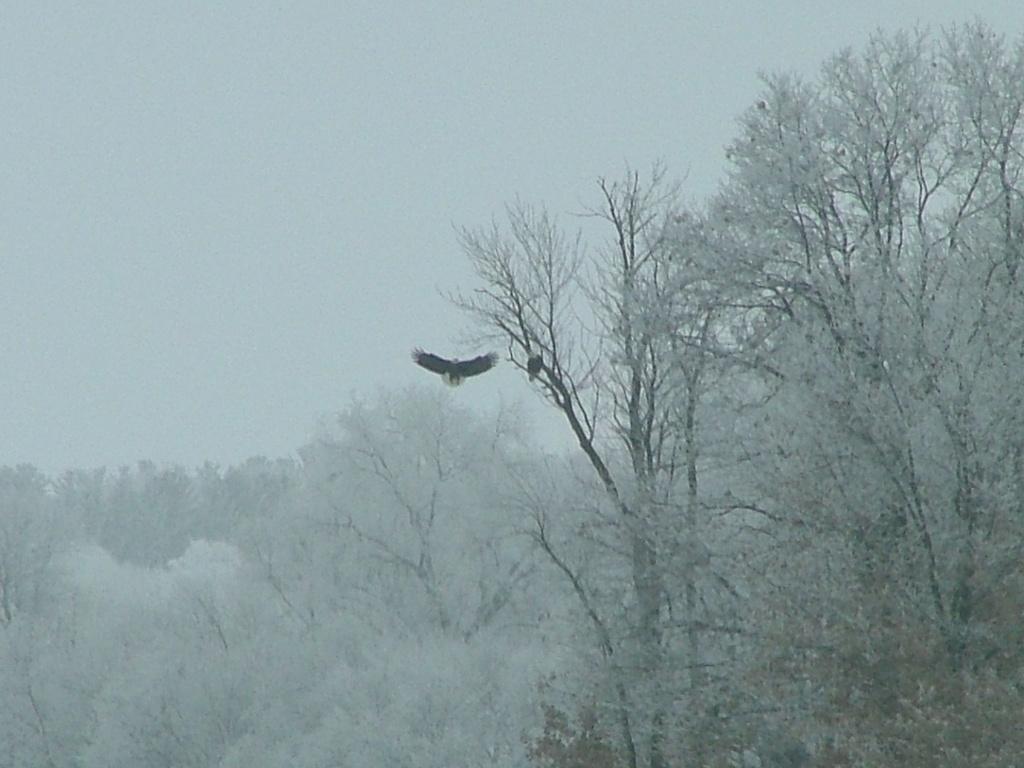In one or two sentences, can you explain what this image depicts? Here in this picture we can see number of trees present, which are fully covered with snow and we can also see an eagle flying in the air and we can see the place is fully covered with fog and the sky is cloudy. 